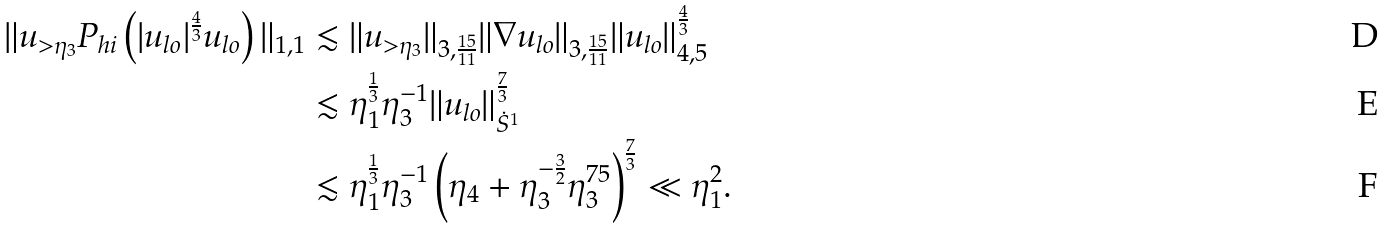Convert formula to latex. <formula><loc_0><loc_0><loc_500><loc_500>\| u _ { > \eta _ { 3 } } P _ { h i } \left ( | u _ { l o } | ^ { \frac { 4 } { 3 } } u _ { l o } \right ) \| _ { 1 , 1 } & \lesssim \| u _ { > \eta _ { 3 } } \| _ { 3 , \frac { 1 5 } { 1 1 } } \| \nabla u _ { l o } \| _ { 3 , \frac { 1 5 } { 1 1 } } \| u _ { l o } \| _ { 4 , 5 } ^ { \frac { 4 } { 3 } } \\ & \lesssim \eta _ { 1 } ^ { \frac { 1 } { 3 } } \eta _ { 3 } ^ { - 1 } \| u _ { l o } \| _ { \dot { S } ^ { 1 } } ^ { \frac { 7 } { 3 } } \\ & \lesssim \eta _ { 1 } ^ { \frac { 1 } { 3 } } \eta _ { 3 } ^ { - 1 } \left ( \eta _ { 4 } + \eta _ { 3 } ^ { - \frac { 3 } { 2 } } \eta _ { 3 } ^ { 7 5 } \right ) ^ { \frac { 7 } { 3 } } \ll \eta _ { 1 } ^ { 2 } .</formula> 